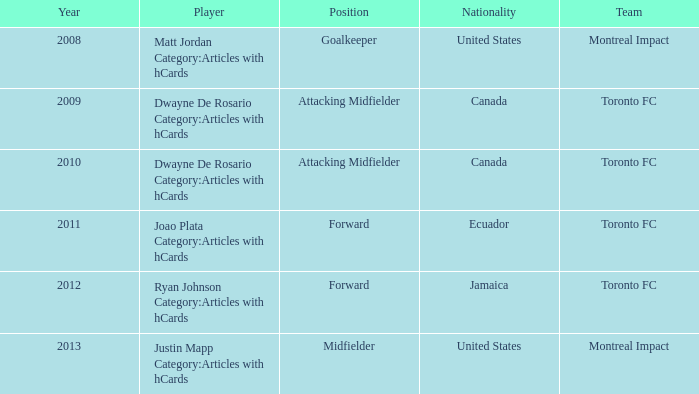What's the nation associated with montreal impact with justin mapp category: articles with hcards involving the competitor? United States. 